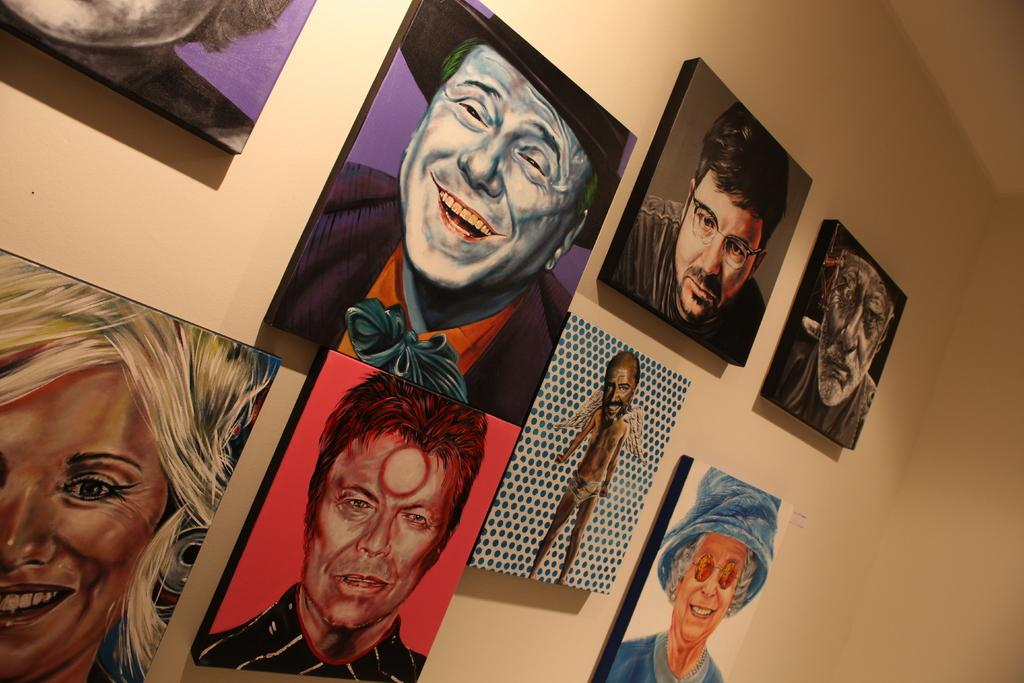What type of decorations can be seen in the image? There are wall hangings in the image. How are the wall hangings positioned in the image? The wall hangings are attached to the wall. What type of insurance is required for the wall hangings in the image? There is no mention of insurance in the image, and it is not necessary for wall hangings. 